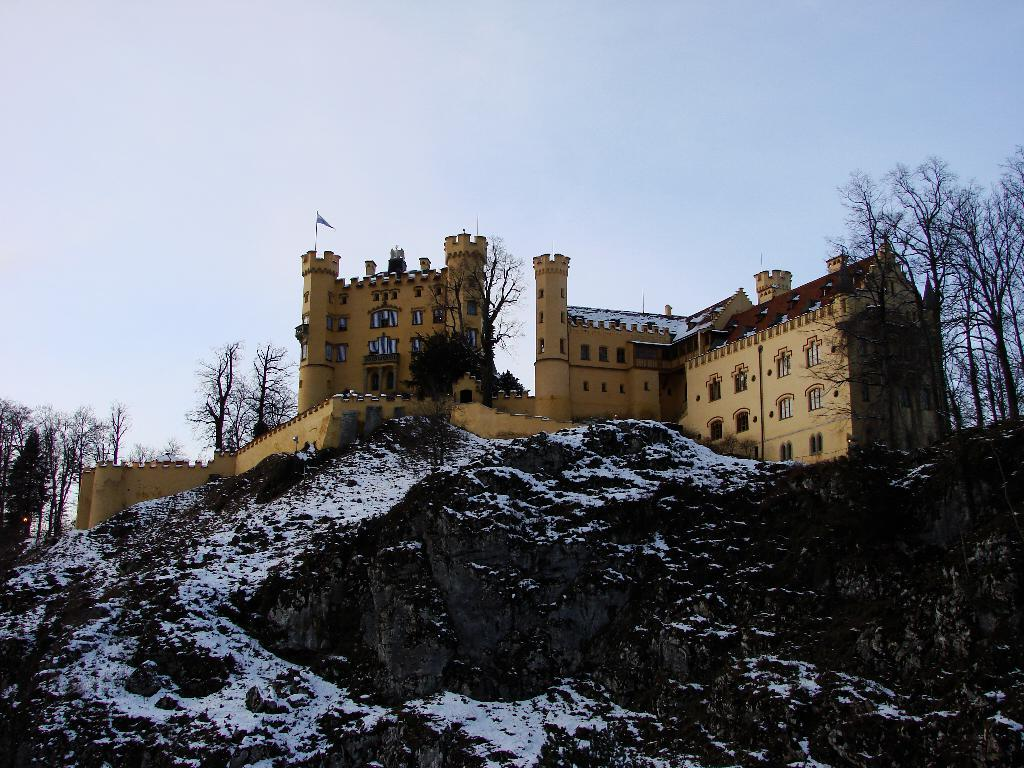What is the main structure in the center of the image? There is a castle in the center of the image. What is located at the bottom of the image? There is a rock at the bottom of the image. What type of vegetation can be seen in the background of the image? There are trees in the background of the image. What else is visible in the background of the image? The sky is visible in the background of the image. What type of rail can be seen connecting the castle to the rock in the image? There is no rail connecting the castle to the rock in the image. How low is the tail of the bird flying in the image? There are no birds present in the image, so there is no tail to measure. 